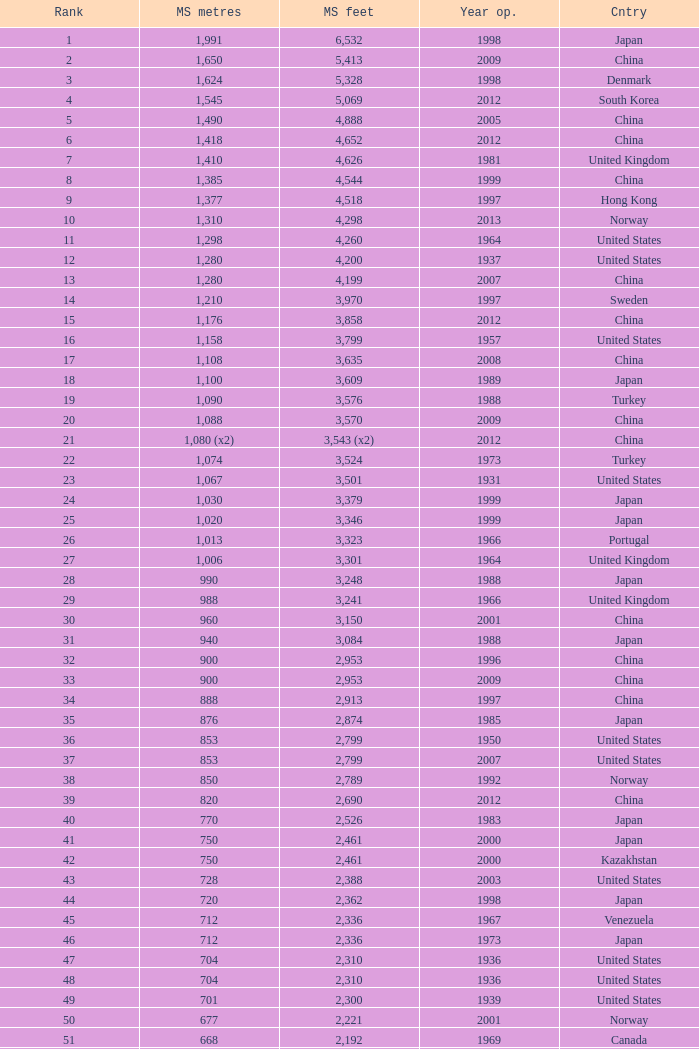What is the main span in feet from a year of 2009 or more recent with a rank less than 94 and 1,310 main span metres? 4298.0. 